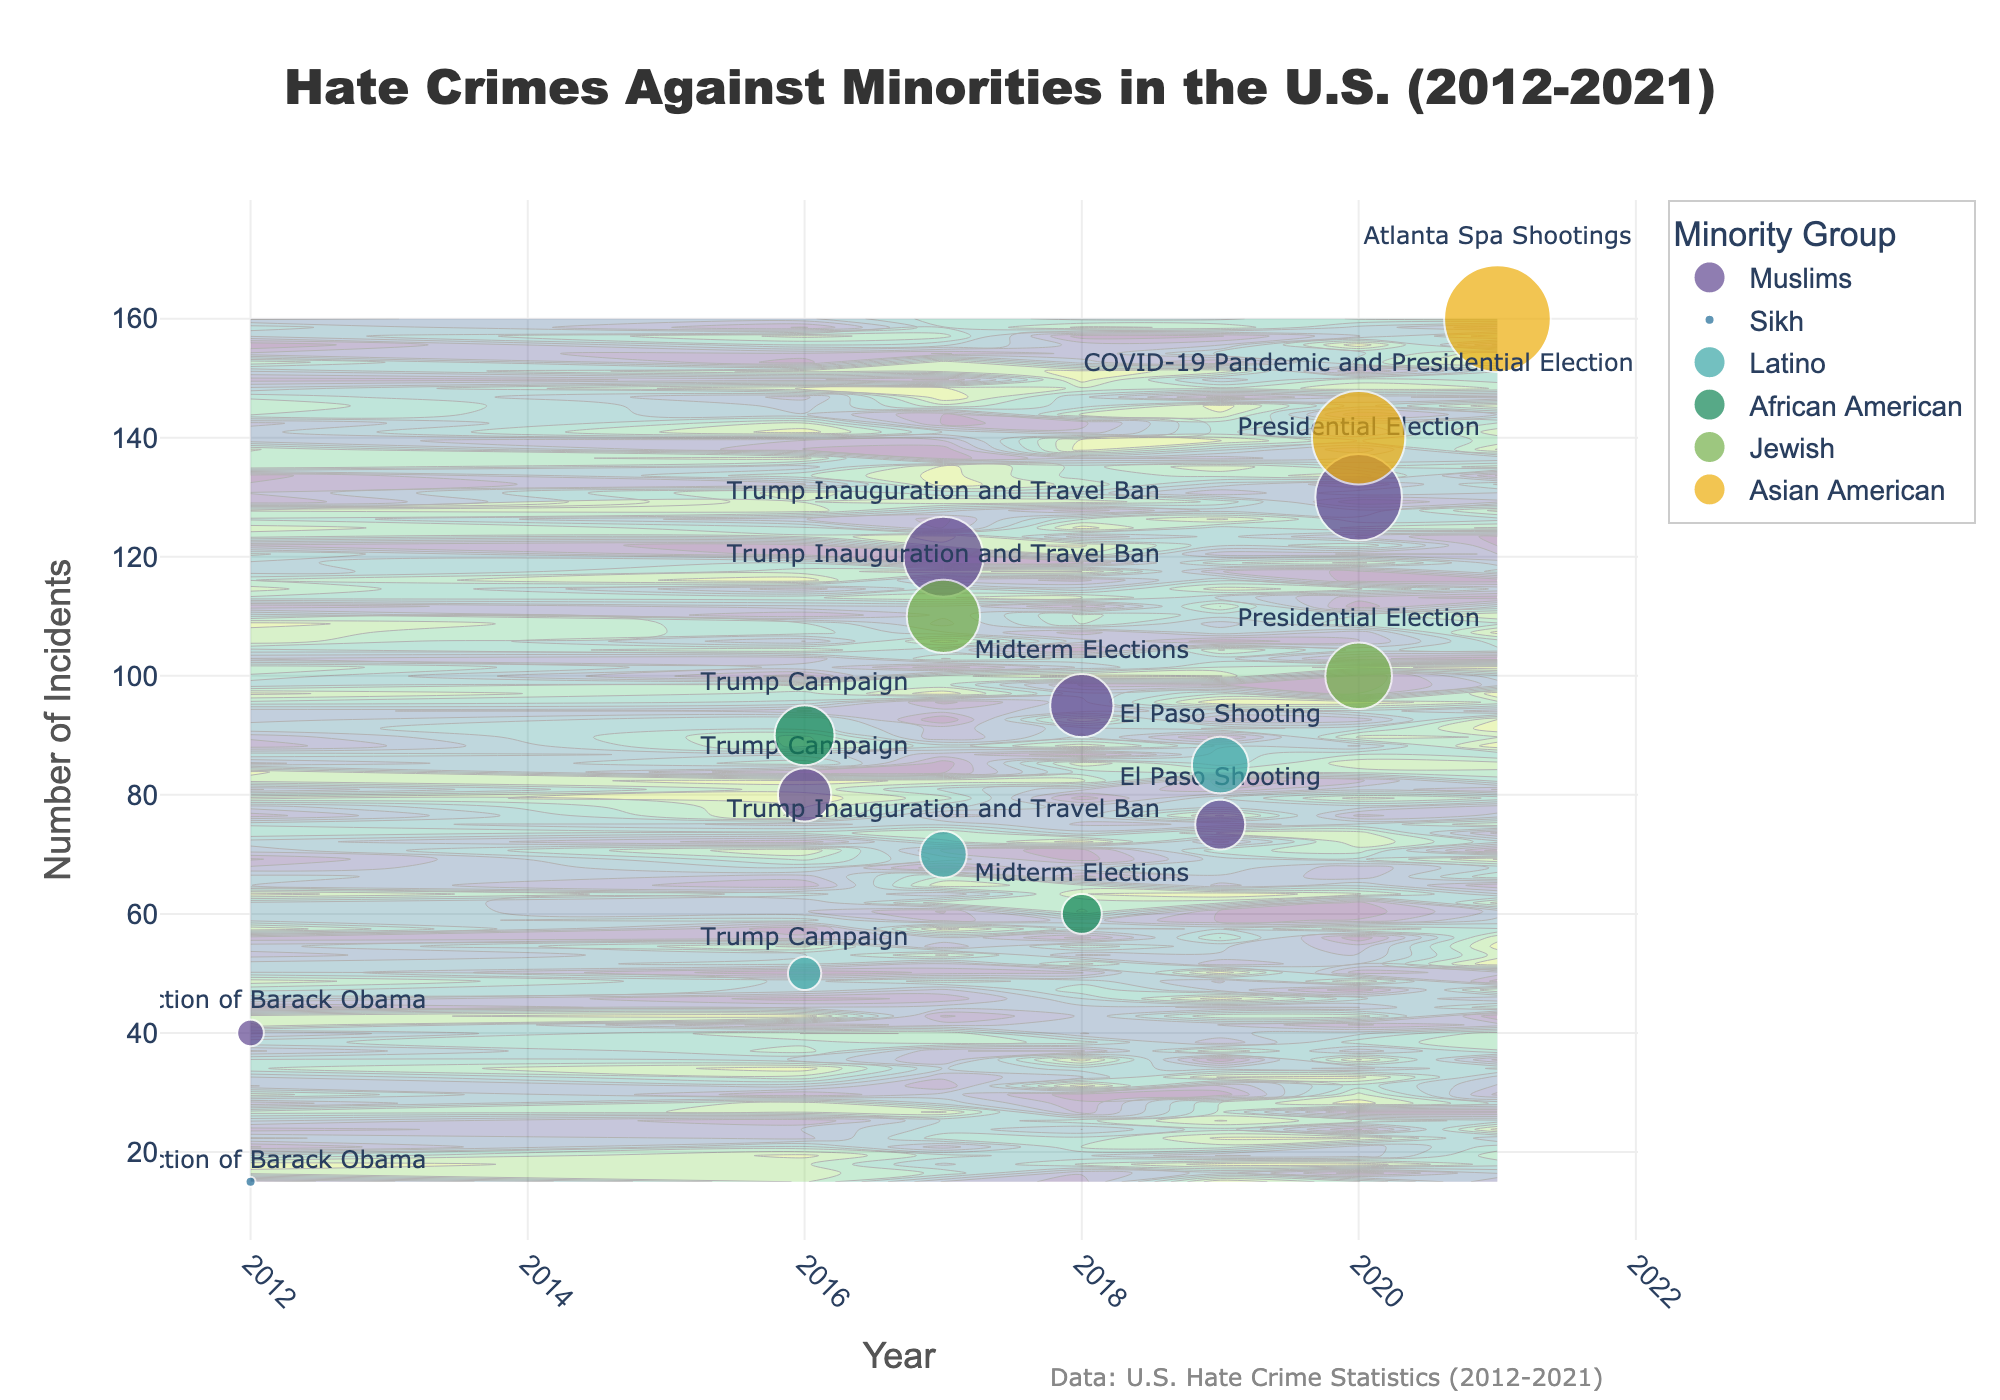What is the title of the figure? The title is displayed at the top of the figure and reads "Hate Crimes Against Minorities in the U.S. (2012-2021)"
Answer: Hate Crimes Against Minorities in the U.S. (2012-2021) Which minority group had the highest number of hate crime incidents in 2021? From the scatter plot markers, the largest number of incidents in 2021 appear for Asian Americans with a value of 160 incidents, indicated by the text label "Atlanta Spa Shootings."
Answer: Asian American How many total incidents were recorded for Muslims in 2017? Look for the markers labeled for Muslims in 2017 on the plot, which is 120 incidents for the "Trump Inauguration and Travel Ban."
Answer: 120 In 2020, which minority group experienced more hate crimes: Jewish or Muslims? Compare the scatter markers for Jewish and Muslims in 2020. Muslims incidents are 130 whereas Jewish incidents are 100.
Answer: Muslims What is the trend in hate crime incidents for Asian Americans from 2020 to 2021? Examine the markers for Asian Americans. In 2020, there are 140 incidents ("COVID-19 Pandemic and Presidential Election"), and in 2021, there are 160 incidents ("Atlanta Spa Shootings"), indicating an increase.
Answer: Increasing Which political event is associated with the rise in hate crimes against Latinos in 2019? Refer to the points for 2019 and the associated text. The event is "El Paso Shooting."
Answer: El Paso Shooting What year saw the sharpest rise in hate crime incidents against Muslims? Compare the number of incidents year over year. The incidents increase sharply from 40 in 2012 to 80 in 2016 during the "Trump Campaign."
Answer: 2016 During the "Trump Campaign" period in 2016, which minority group experienced the highest number of incidents? Compare the markers for all the groups in 2016. African Americans had the highest with 90 incidents.
Answer: African American What is the difference in the number of incidents for Jewish people between 2017 and 2020? Subtract the number of incidents for Jewish people in 2017 (110) from that in 2020 (100), resulting in a difference of 10.
Answer: 10 How does the number of hate crimes against Sikhs in 2012 compare to Muslims in the same year? Compare the markers for Sikhs and Muslims in 2012. Sikhs experienced 15 incidents whereas Muslims experienced 40 incidents.
Answer: Muslims had more 